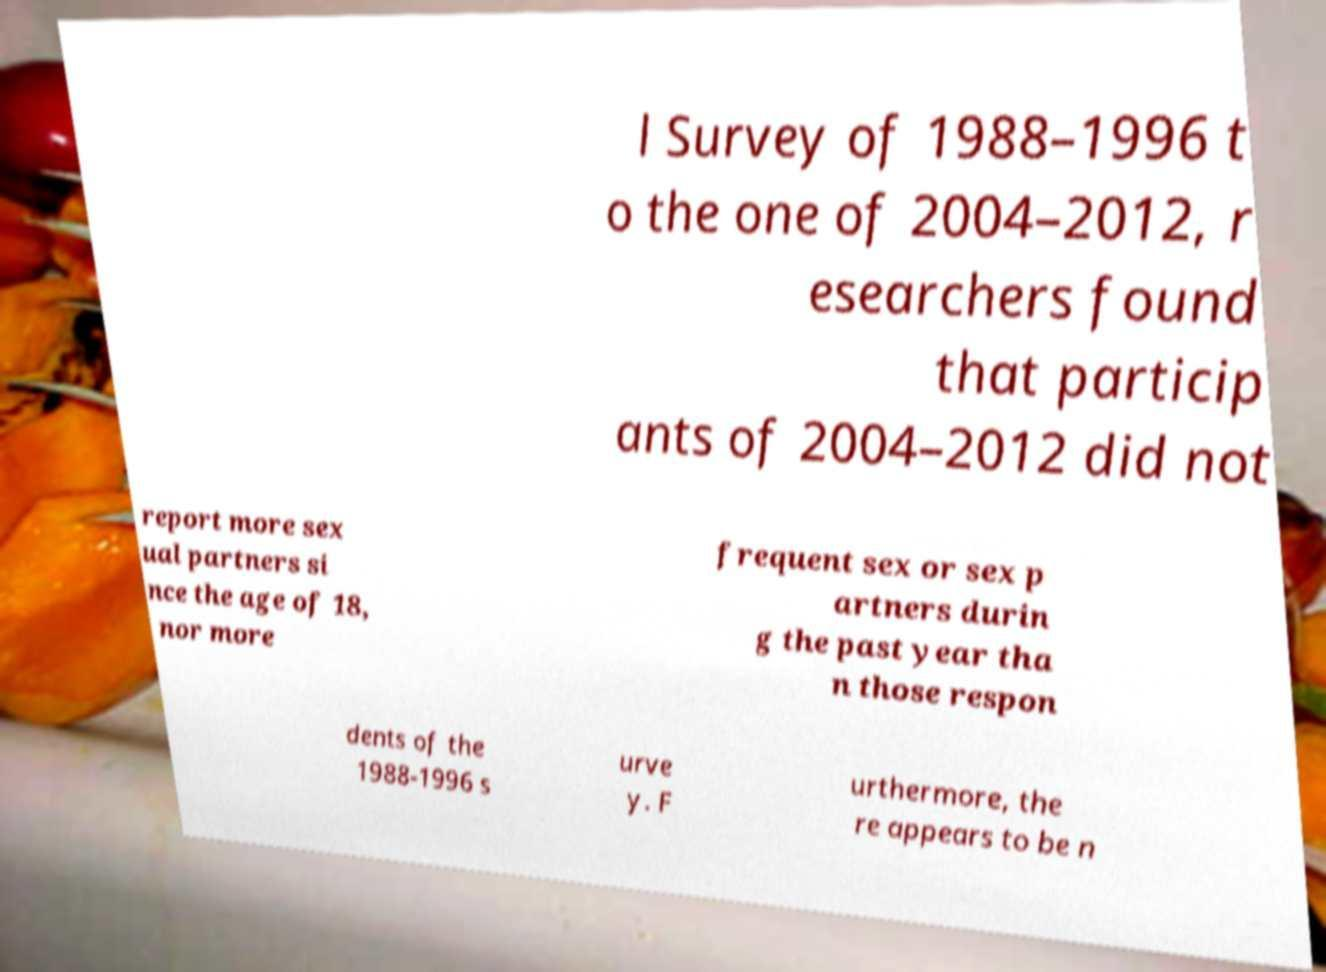Please identify and transcribe the text found in this image. l Survey of 1988–1996 t o the one of 2004–2012, r esearchers found that particip ants of 2004–2012 did not report more sex ual partners si nce the age of 18, nor more frequent sex or sex p artners durin g the past year tha n those respon dents of the 1988-1996 s urve y. F urthermore, the re appears to be n 